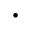<formula> <loc_0><loc_0><loc_500><loc_500>\cdot</formula> 